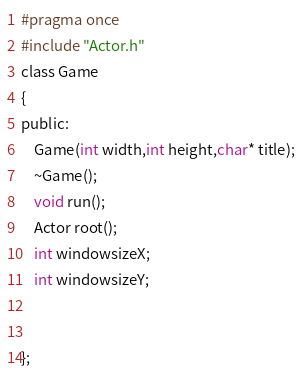Convert code to text. <code><loc_0><loc_0><loc_500><loc_500><_C_>#pragma once
#include "Actor.h"
class Game
{
public:
	Game(int width,int height,char* title);
	~Game();
	void run();
	Actor root();
	int windowsizeX;
	int windowsizeY;
	
	
};

</code> 